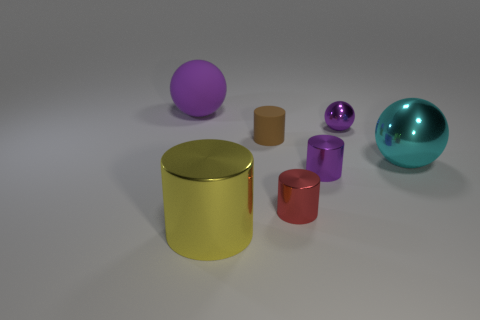How many objects are in this image, and can you describe their colors and materials? There are six objects in the image. From left to right: a large purple sphere with a shiny surface, a large yellow rubber cylinder, a small brown matte cylinder, a small red matte cylinder, a small shiny purple sphere, and a large shiny teal ellipsoid. 